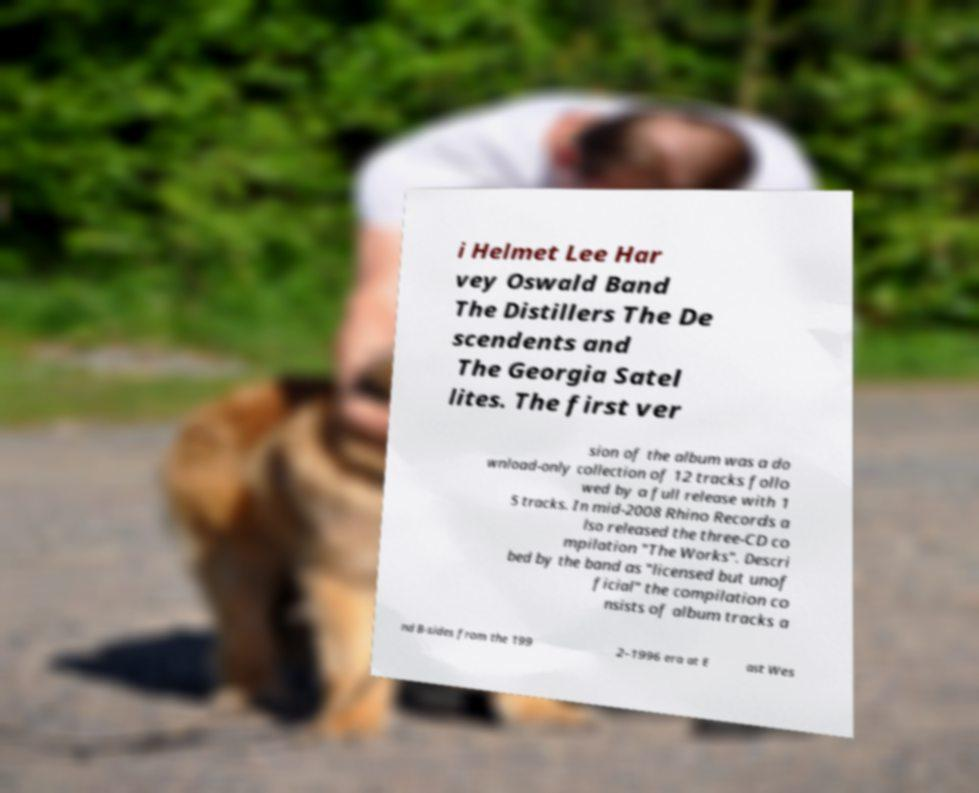Could you extract and type out the text from this image? i Helmet Lee Har vey Oswald Band The Distillers The De scendents and The Georgia Satel lites. The first ver sion of the album was a do wnload-only collection of 12 tracks follo wed by a full release with 1 5 tracks. In mid-2008 Rhino Records a lso released the three-CD co mpilation "The Works". Descri bed by the band as "licensed but unof ficial" the compilation co nsists of album tracks a nd B-sides from the 199 2–1996 era at E ast Wes 